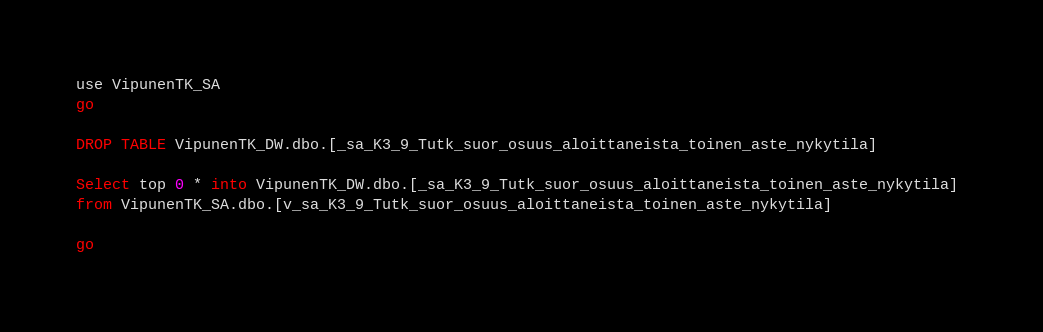<code> <loc_0><loc_0><loc_500><loc_500><_SQL_>use VipunenTK_SA
go

DROP TABLE VipunenTK_DW.dbo.[_sa_K3_9_Tutk_suor_osuus_aloittaneista_toinen_aste_nykytila]

Select top 0 * into VipunenTK_DW.dbo.[_sa_K3_9_Tutk_suor_osuus_aloittaneista_toinen_aste_nykytila] 
from VipunenTK_SA.dbo.[v_sa_K3_9_Tutk_suor_osuus_aloittaneista_toinen_aste_nykytila]

go</code> 